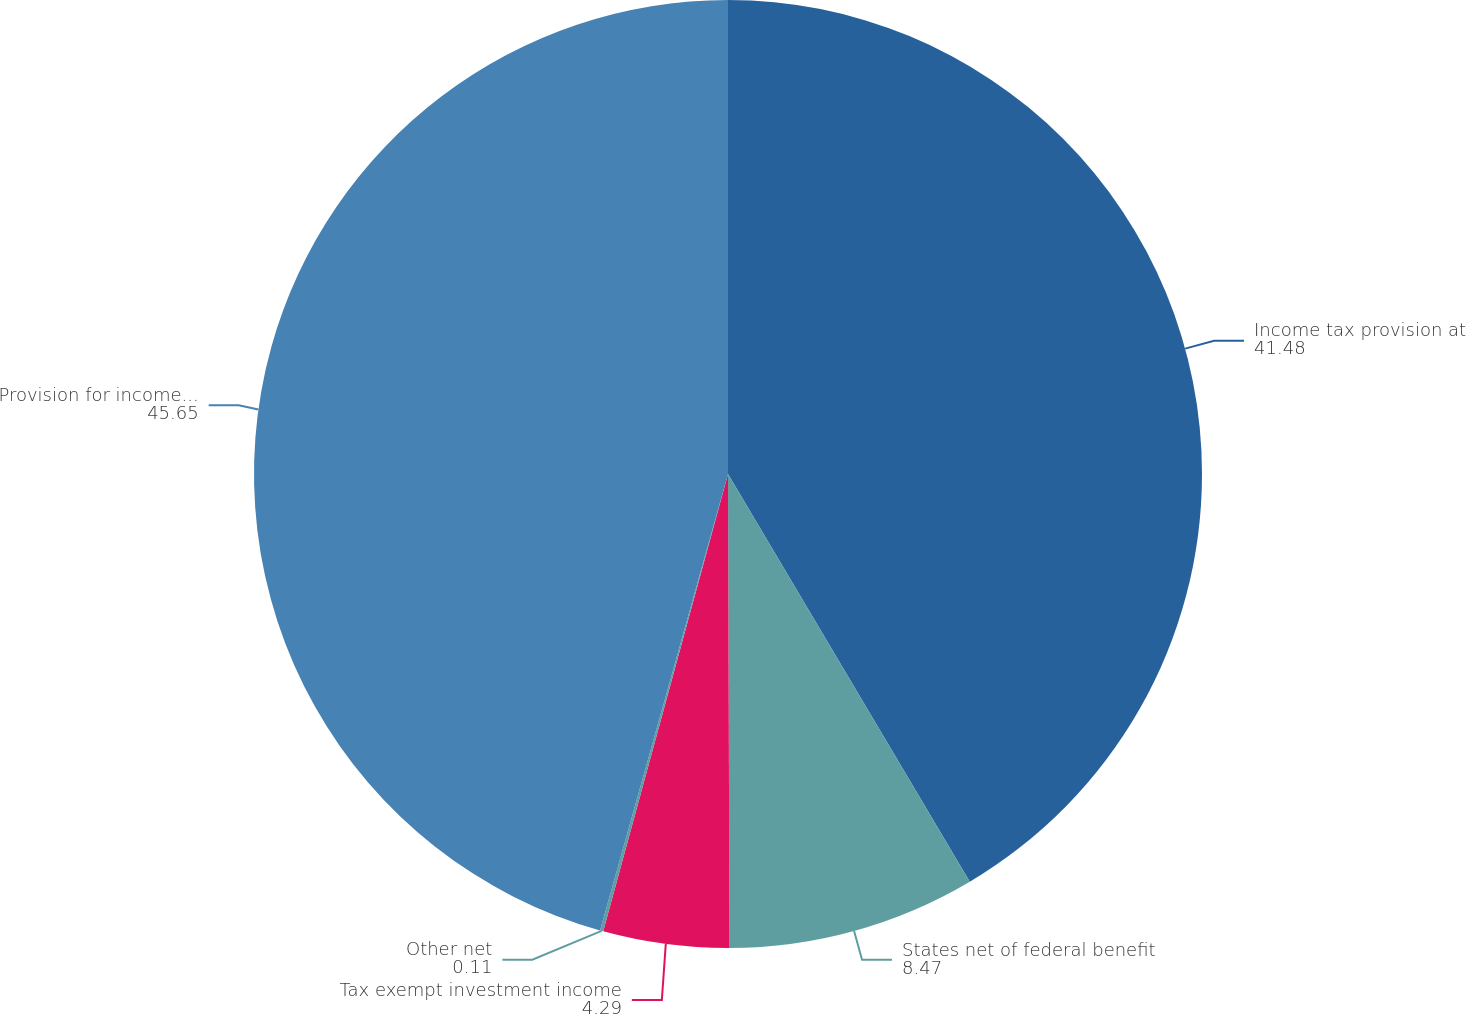Convert chart to OTSL. <chart><loc_0><loc_0><loc_500><loc_500><pie_chart><fcel>Income tax provision at<fcel>States net of federal benefit<fcel>Tax exempt investment income<fcel>Other net<fcel>Provision for income taxes<nl><fcel>41.48%<fcel>8.47%<fcel>4.29%<fcel>0.11%<fcel>45.65%<nl></chart> 